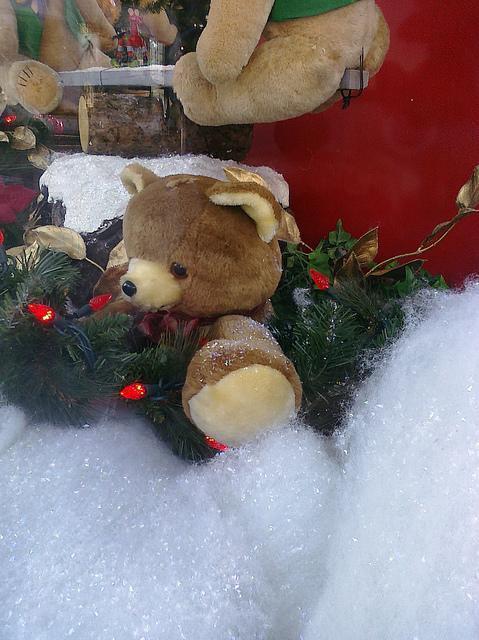How many teddy bears can be seen?
Give a very brief answer. 3. 